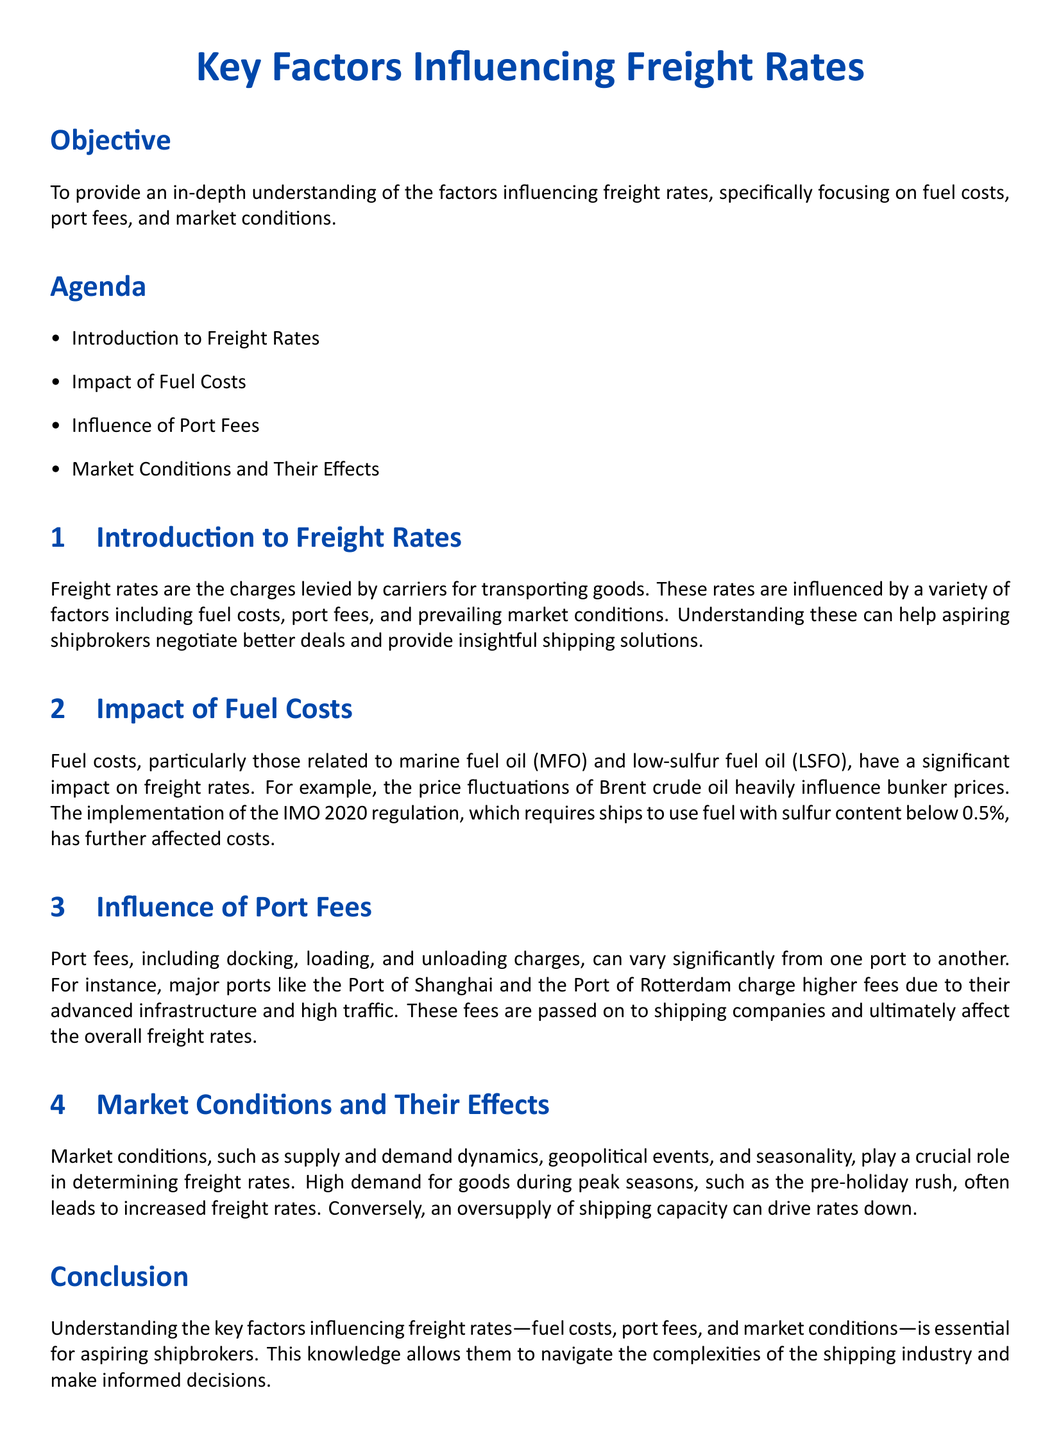What are the key factors influencing freight rates? The lesson plan identifies the key factors influencing freight rates as fuel costs, port fees, and market conditions.
Answer: Fuel costs, port fees, and market conditions What is the main focus of the lesson objective? The lesson objective aims to provide an in-depth understanding of the factors influencing freight rates for aspiring shipbrokers.
Answer: Understanding freight rates What regulation affected fuel costs in maritime trade? The document mentions the implementation of the IMO 2020 regulation, which affects fuel costs related to sulfur content.
Answer: IMO 2020 Which ports are mentioned as having higher fees? The Port of Shanghai and the Port of Rotterdam are specifically cited for charging higher port fees.
Answer: Port of Shanghai and Port of Rotterdam During what season do freight rates typically increase? The document states that high demand during peak seasons, such as the pre-holiday rush, often leads to increased freight rates.
Answer: Pre-holiday rush Name one book listed as an additional resource. The document provides titles for further reading, and one of them is "Maritime Economics" by Martin Stopford.
Answer: Maritime Economics What is a significant factor that affects the supply and demand dynamics? The lesson discusses geopolitical events as a crucial factor influencing supply and demand in maritime trade.
Answer: Geopolitical events What type of costs are related to marine fuel oil? The document indicates that fuel costs related to marine fuel oil (MFO) and low-sulfur fuel oil (LSFO) are significant factors.
Answer: Marine fuel oil and low-sulfur fuel oil Which organization’s website is suggested as a resource? The International Maritime Organization is listed as a website for additional resources related to maritime trade.
Answer: International Maritime Organization 